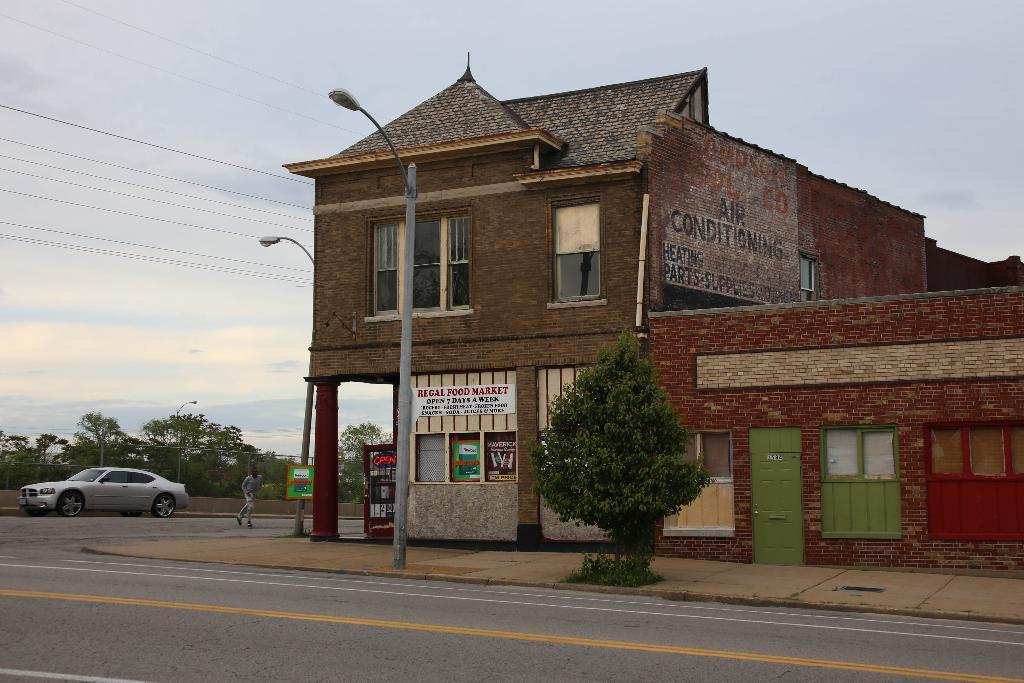How would you summarize this image in a sentence or two? In this image we can see buildings, windows, doors, texts written on the wall, board on the light pole, boards, car on the road, a person is running on the road, light poles, fence, electric wires, trees and clouds in the sky. 